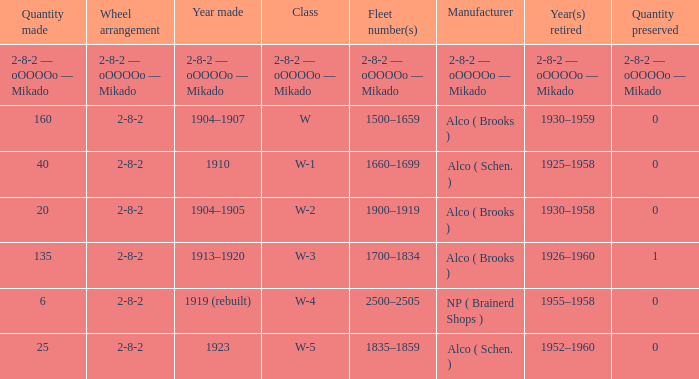Which class had a quantity made of 20? W-2. 